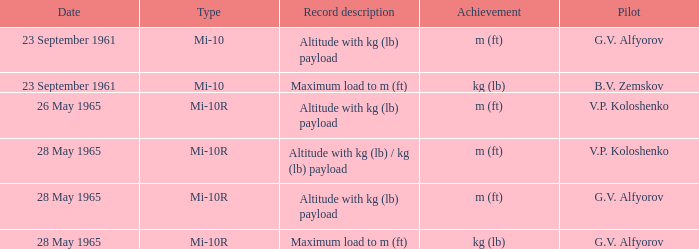What kind of elevation record was accomplished by pilot g.v. alfyorov with a kg (lb) payload? Mi-10, Mi-10R. 